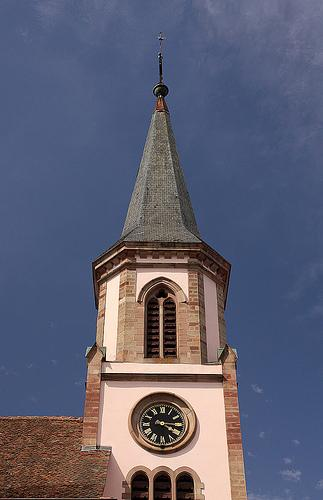Narrate the scene depicted in the image, focusing on the clock and its surroundings. A black clock with gold accents and Roman numerals is mounted on a pink wall of a building with an adjacent triangular tower and a red brick area. Describe the structure and key elements of the building the clock is on. The building has a light pink wall, with a tower featuring a clock, an arch window at the top, and brick and shingle textures. Highlight the building's major characteristics in the image. The building has a pink wall, red brick area, an arch window at the top, and an adjacent roof with red and brown shingles. Talk about the clock on a tower and its characteristics. The tower features a black clock with gold Roman numerals, a brick side, and arch windows. Emphasize the color and texture of the wall in the image. The wall of the building is painted light pink and has a distinct red brick area. Illustrate the clock's details, focusing on its design elements. The round clock on the wall features black and gold accents, Roman numerals, and hands that display a time of 4:15. Characterize the appearance of the sky in the image. The blue sky has tiny white wispy clouds scattered across it. Mention the most prominent object in the image and its key features. A black round clock with gold Roman numerals is on the wall, displaying a time of 4:15. Describe the roof and tower in the image and their distinct features. The roof has red and brown shingles, and there's a triangular tower with a black clock showing 4:15 and an arch window at its top. Point out the building's windows and their unique aspects. The tower has arch windows and a decorative window with brown shutters at the top. 